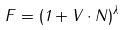<formula> <loc_0><loc_0><loc_500><loc_500>F = ( 1 + V \cdot N ) ^ { \lambda }</formula> 